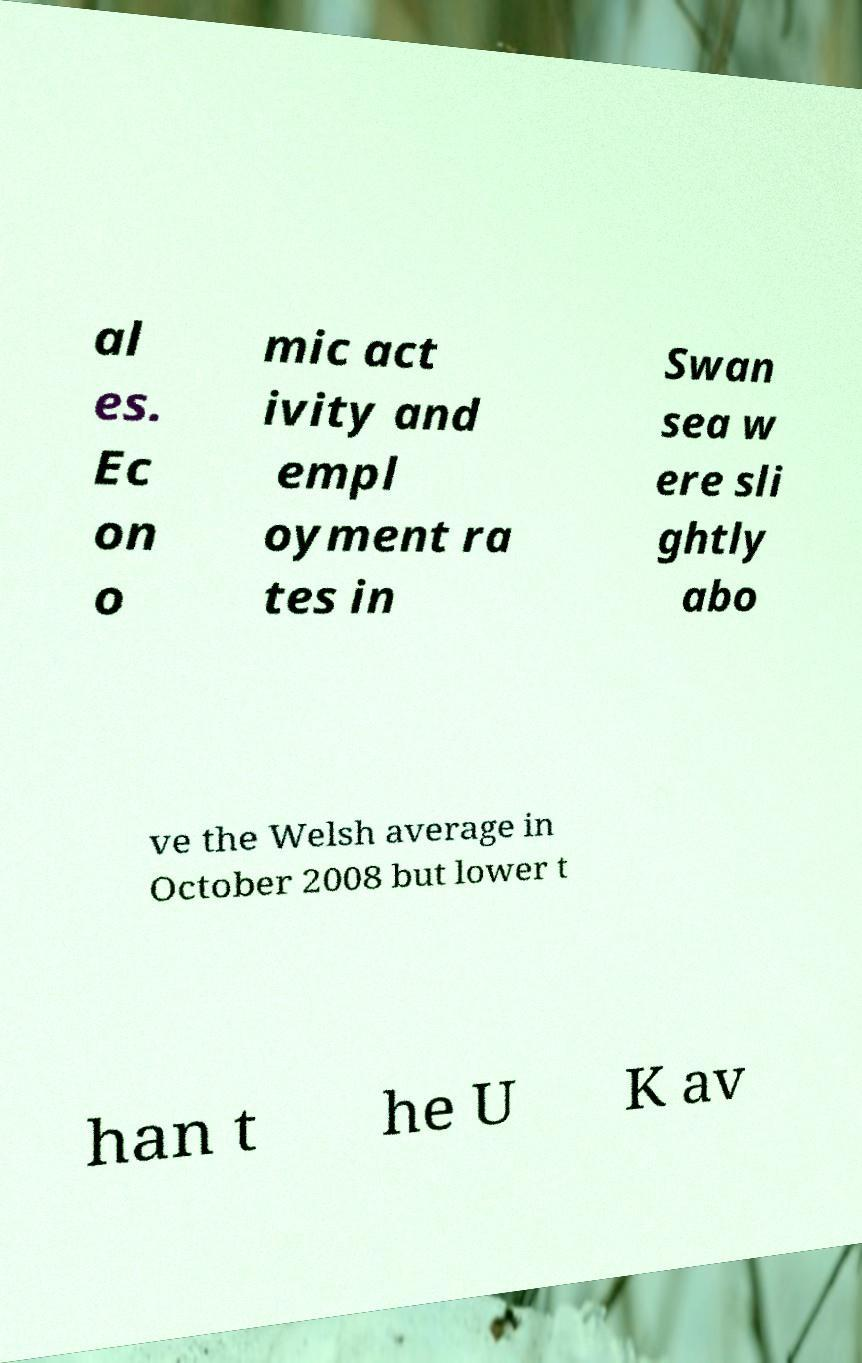Can you read and provide the text displayed in the image?This photo seems to have some interesting text. Can you extract and type it out for me? al es. Ec on o mic act ivity and empl oyment ra tes in Swan sea w ere sli ghtly abo ve the Welsh average in October 2008 but lower t han t he U K av 